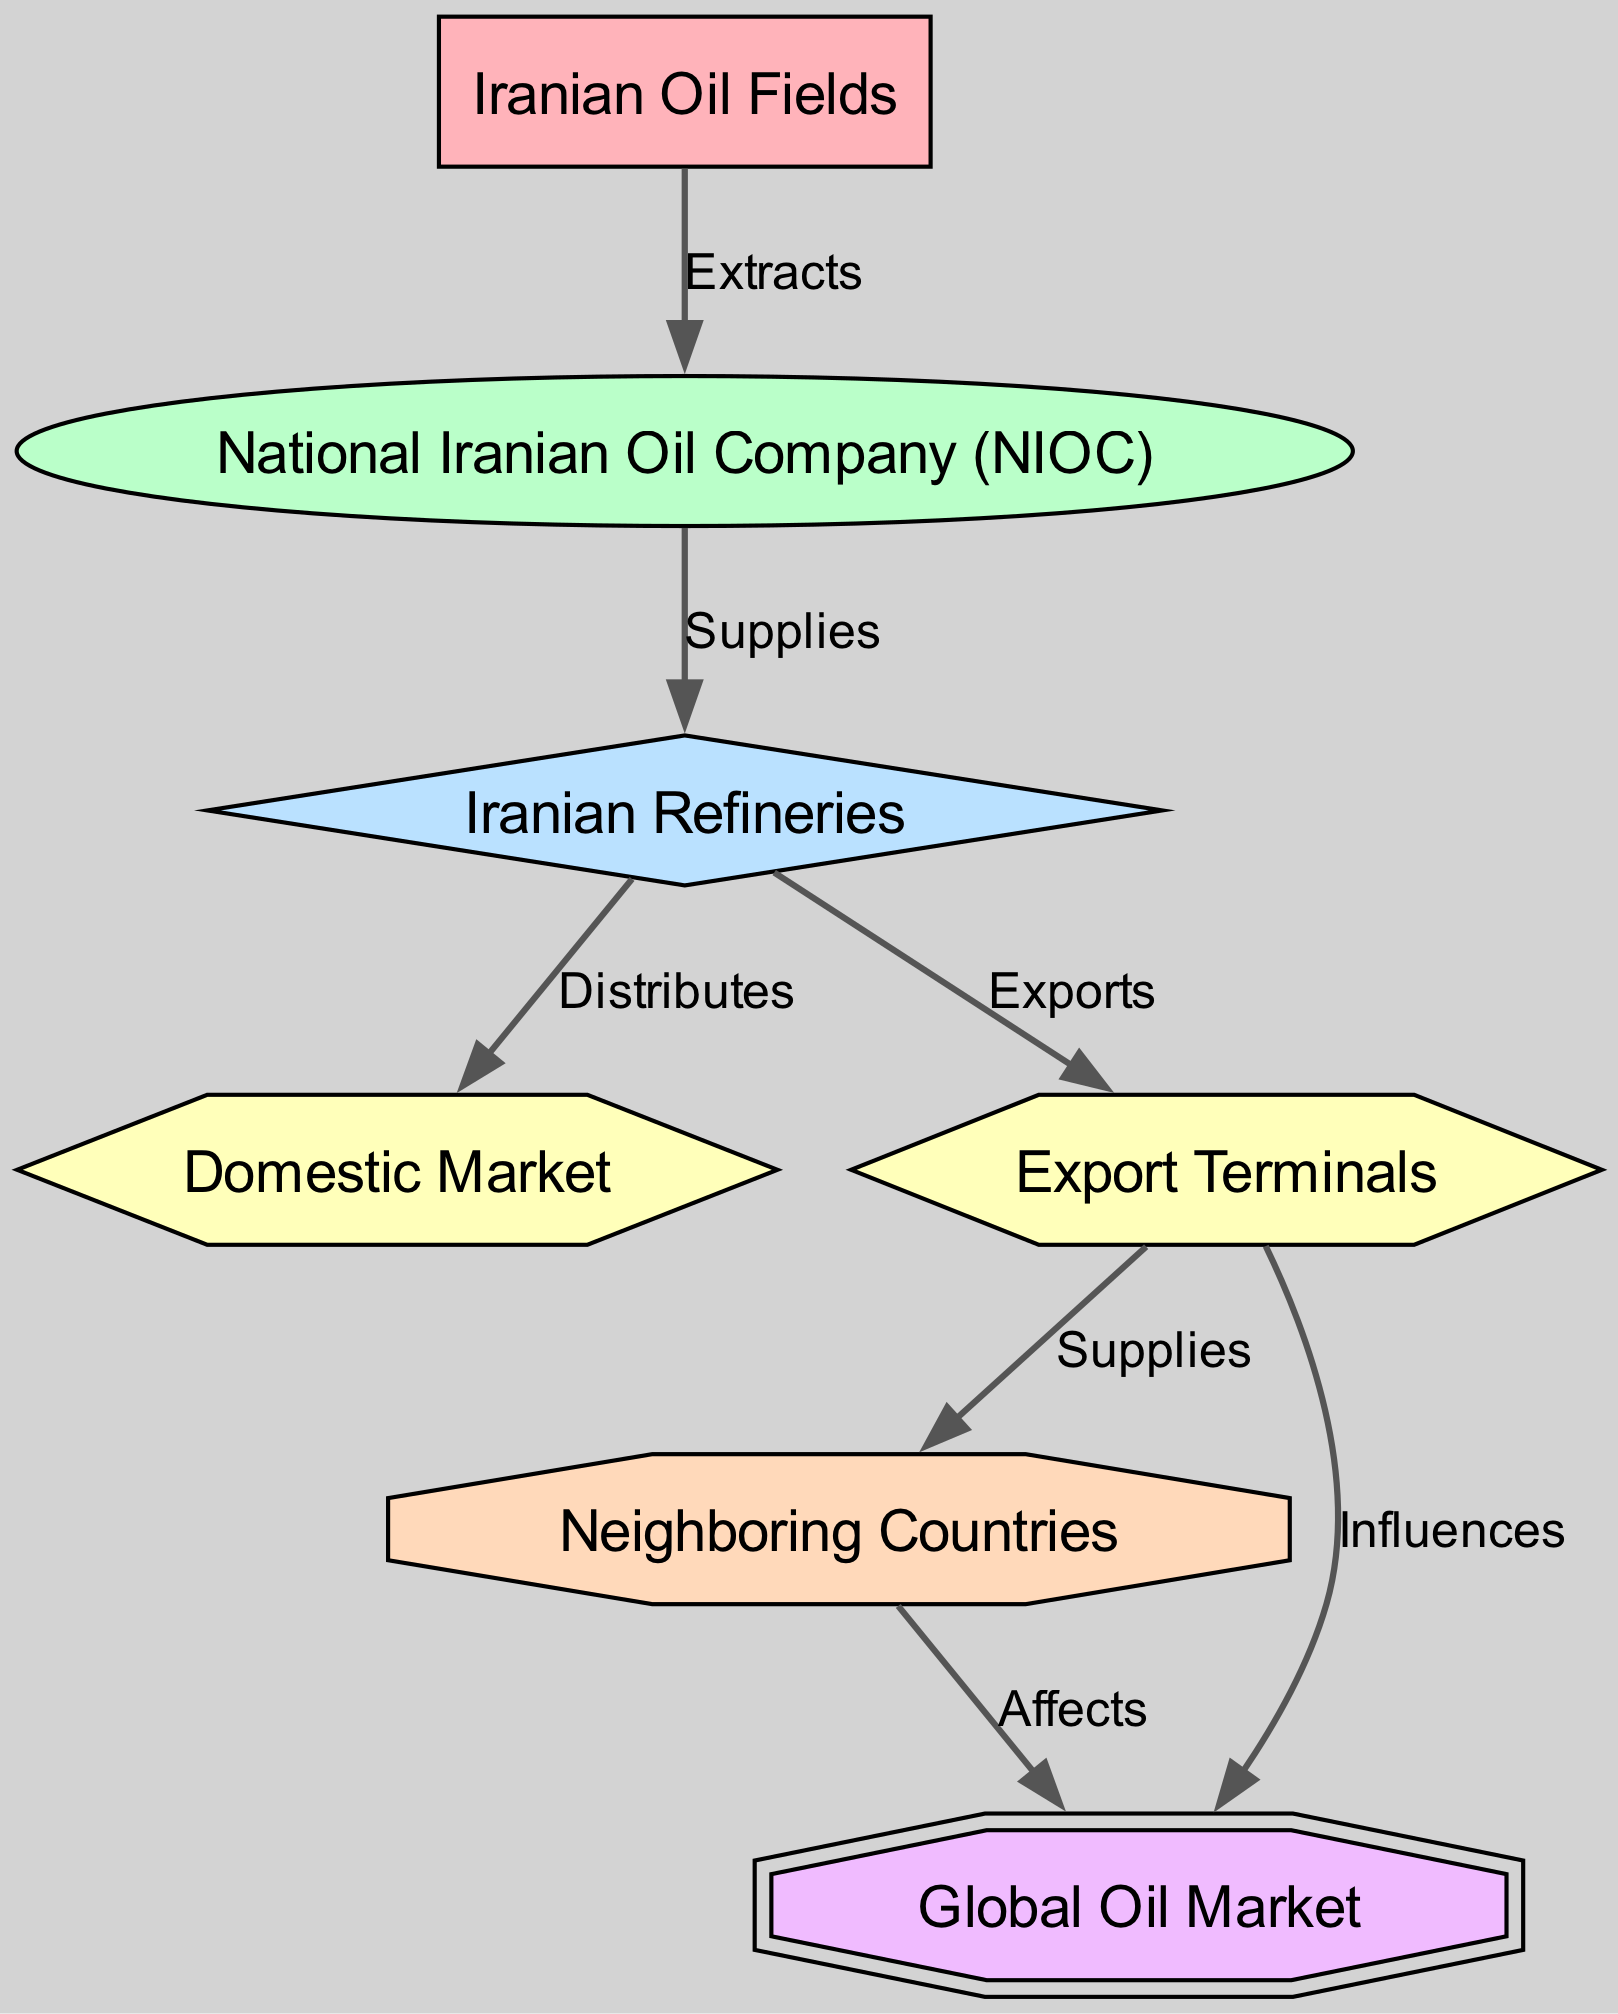What is the primary source of oil in the food chain? The diagram starts with "Iranian Oil Fields" as the producer of oil, which is the initial source in the food chain.
Answer: Iranian Oil Fields How many types of consumers are in the diagram? By examining the elements, there are four types of consumers: primary, secondary, tertiary, and quaternary.
Answer: Four What relationship connects the Iranian Refineries and the Domestic Market? The edge from "Iranian Refineries" to "Domestic Market" indicates that it "Distributes" oil to the domestic sector.
Answer: Distributes Which entity exports oil to neighboring countries? The edge shows that "Export Terminals" supply oil to "Neighboring Countries," indicating that the export process involves this connection.
Answer: Export Terminals What type of consumer is the Global Oil Market? The "Global Oil Market" is classified as the apex consumer, representing the top level in the food chain hierarchy.
Answer: Apex consumer How does the export of oil influence the Global Oil Market? The diagram shows that "Export Terminals" "Influences" the "Global Oil Market," demonstrating a direct relationship affecting global oil dynamics.
Answer: Influences What role does the National Iranian Oil Company play in the food chain? The "National Iranian Oil Company (NIOC)" serves as the primary consumer, receiving oil extracted from the Iranian Oil Fields to facilitate distribution.
Answer: Primary consumer Which consumers receive supplies from the Export Terminals? The "Neighboring Countries" and the "Global Oil Market" are the consumers supplied by the "Export Terminals," as represented by the diagram's edges.
Answer: Neighboring Countries, Global Oil Market What is the flow of oil from Iranian Oil Fields to Neighboring Countries? The flow begins at "Iranian Oil Fields," which supplies the "National Iranian Oil Company," leading to "Iranian Refineries," then exporting through "Export Terminals" to "Neighboring Countries."
Answer: Extracts, Supplies, Distributes, Exports, Supplies 